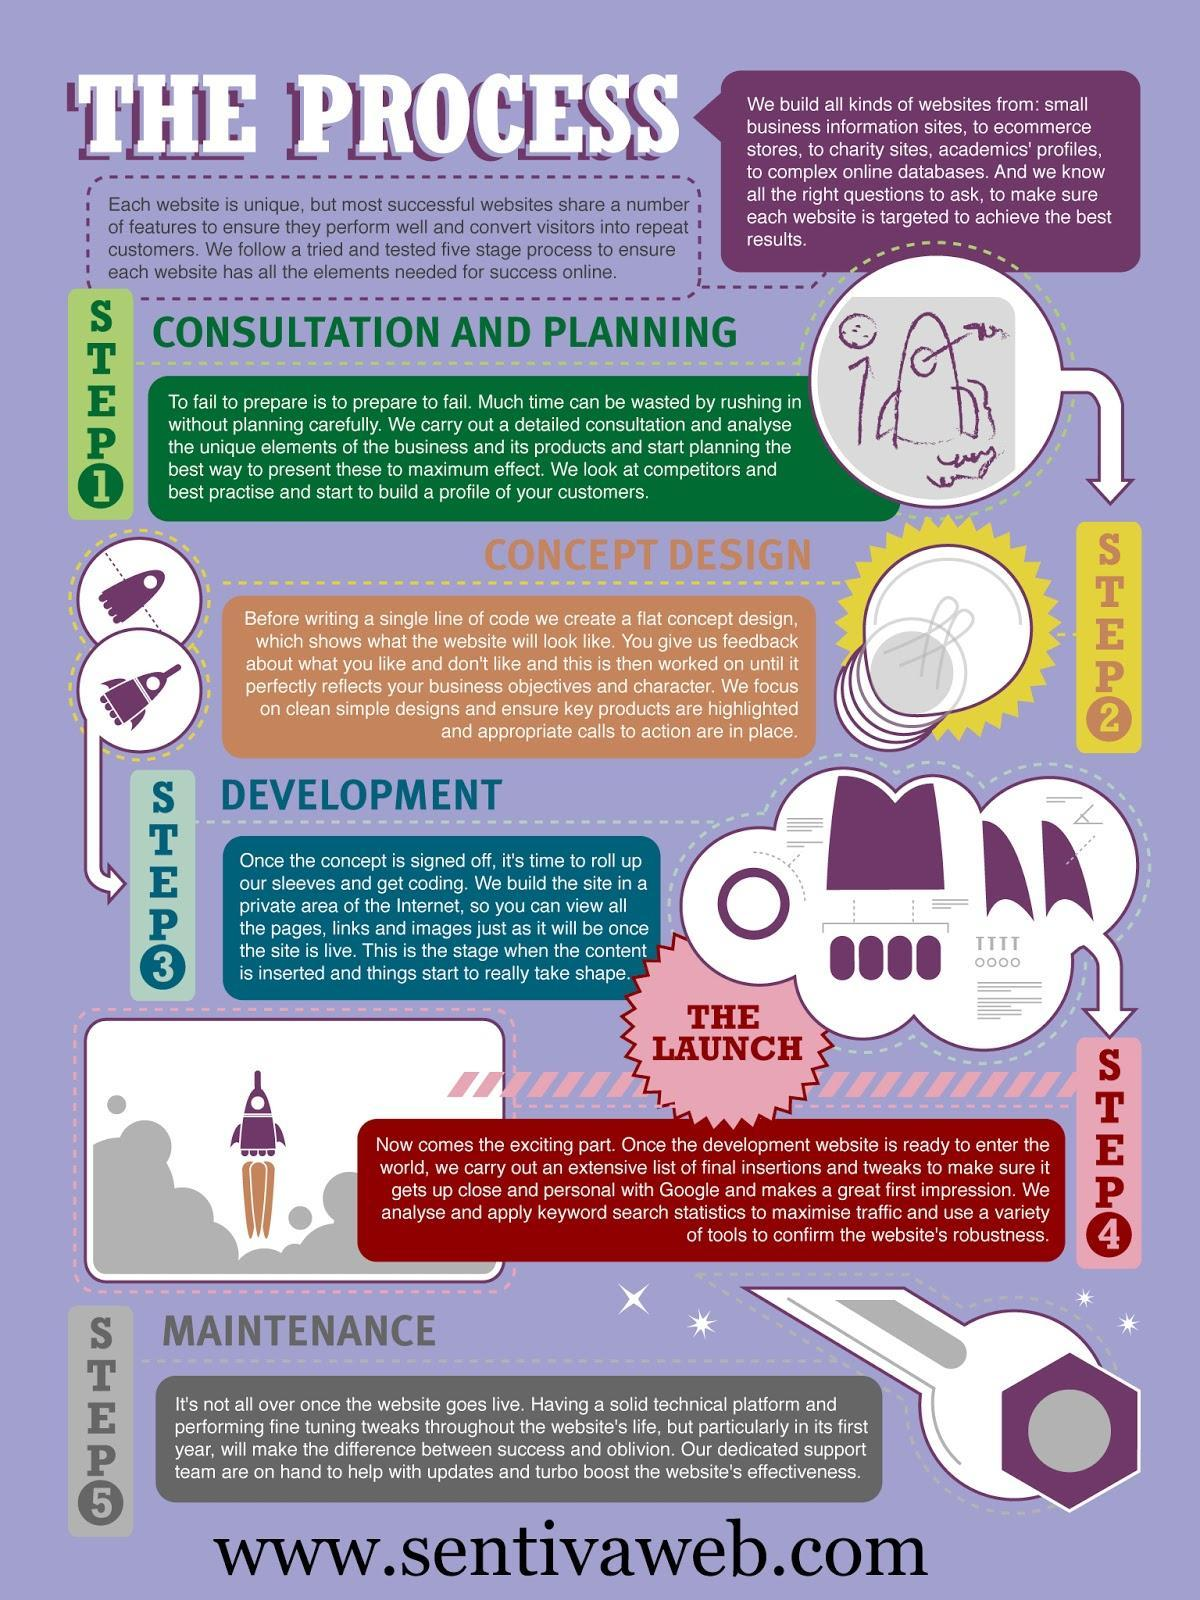In which step do we help with updates and improve website's effectiveness?
Answer the question with a short phrase. Maintenance What is the next step once the development is completed? The launch In which step do we start coding? development What step comes after planning? concept design In which step is a concept design created  - step 1, step 2 or step 3? step 2 In which step is content inserted into the website? development what is the first step in building a website? consultation and planning 